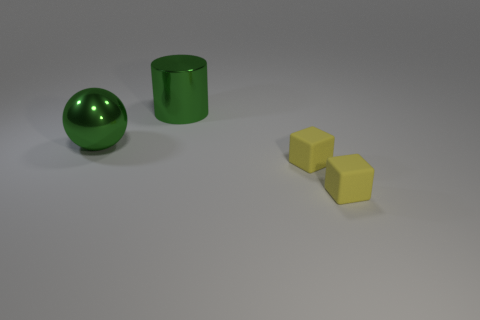There is a shiny object left of the cylinder; is it the same color as the large object behind the big green sphere?
Make the answer very short. Yes. Is there a rubber cube in front of the large green object that is behind the metallic ball?
Give a very brief answer. Yes. Is the number of small rubber cubes that are to the left of the cylinder less than the number of green spheres that are on the right side of the big green ball?
Your response must be concise. No. What number of small things are yellow things or red shiny blocks?
Provide a short and direct response. 2. What is the shape of the object that is the same material as the big green sphere?
Give a very brief answer. Cylinder. Is the number of things in front of the big green sphere less than the number of large brown rubber cubes?
Your answer should be compact. No. How many rubber objects are either small objects or big green cylinders?
Your response must be concise. 2. Are there any yellow matte things that have the same size as the green metallic cylinder?
Your response must be concise. No. There is a large metallic object that is the same color as the sphere; what is its shape?
Keep it short and to the point. Cylinder. How many shiny cylinders are the same size as the ball?
Offer a terse response. 1. 